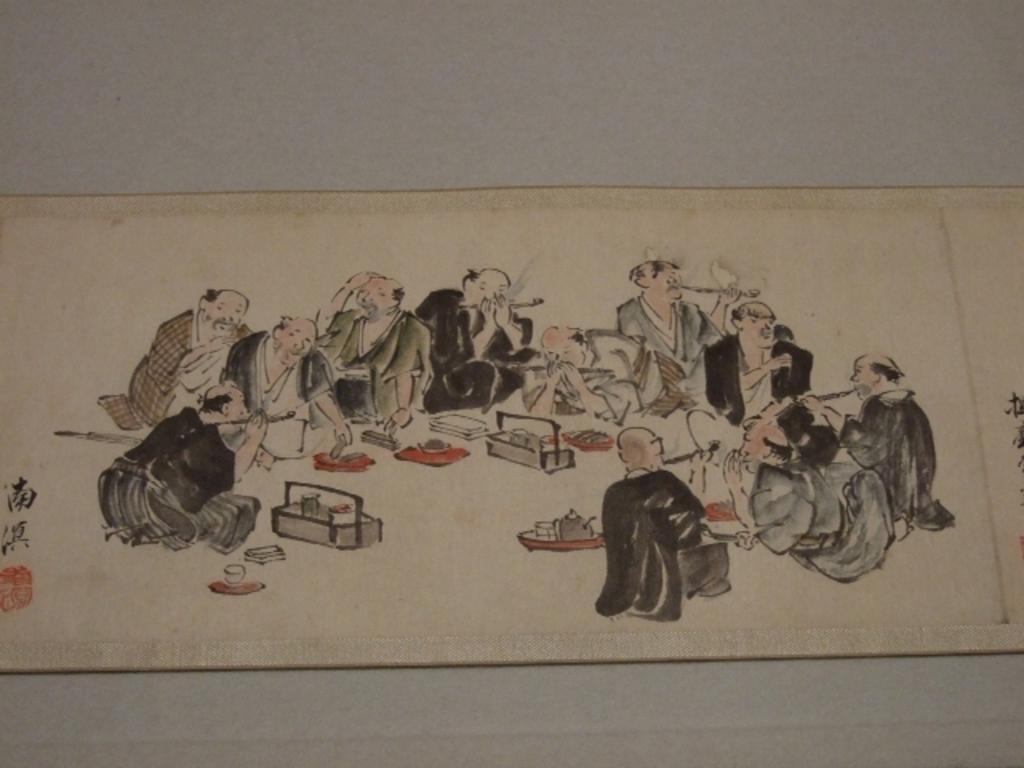Describe this image in one or two sentences. In the picture I can see a sketch of people and some other things. This object on a white color surface. 